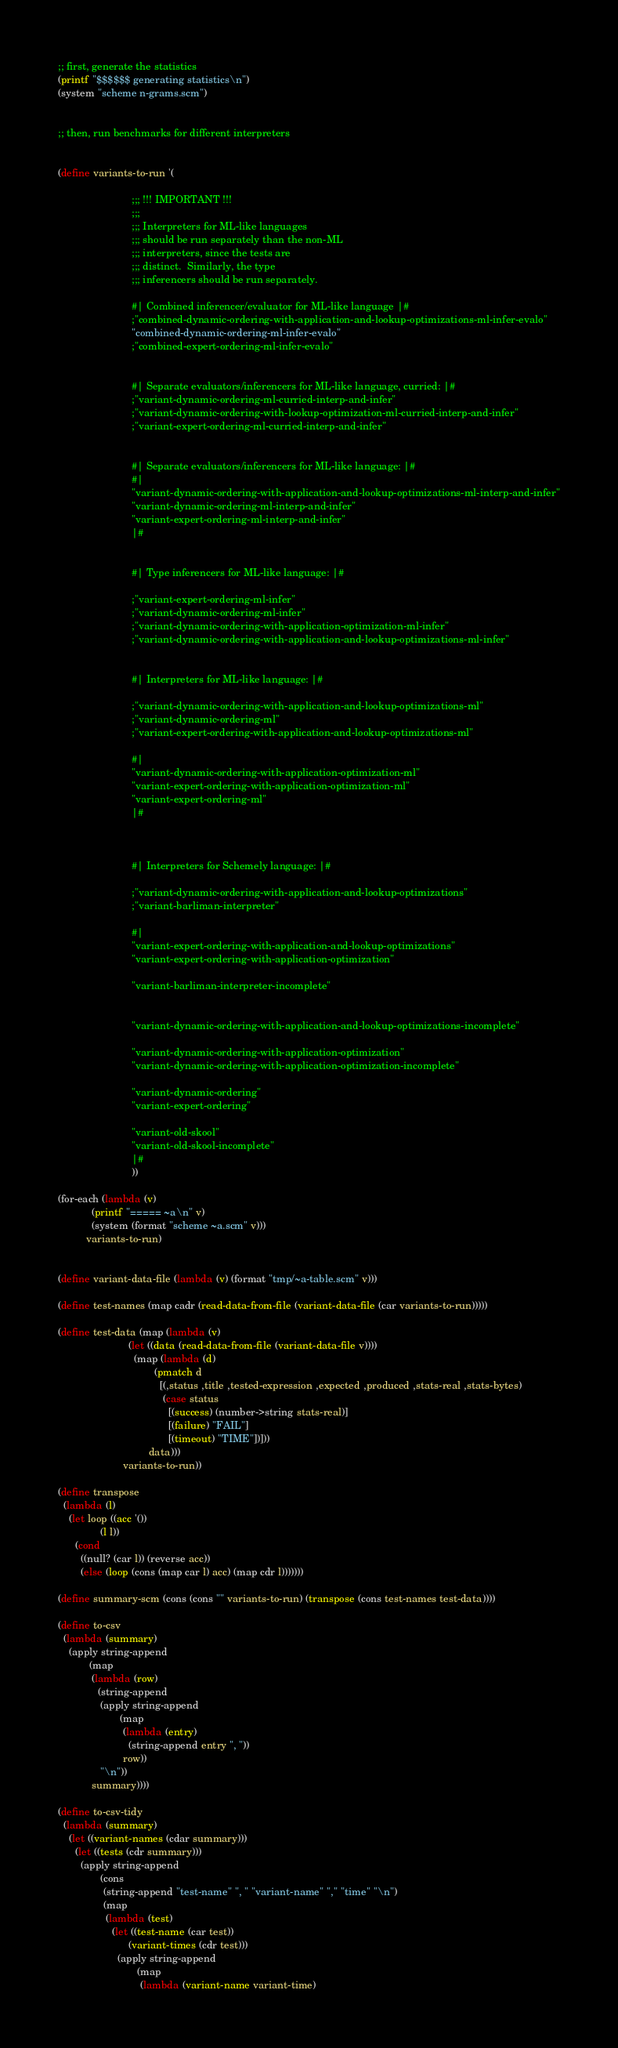<code> <loc_0><loc_0><loc_500><loc_500><_Scheme_>;; first, generate the statistics
(printf "$$$$$$ generating statistics\n")
(system "scheme n-grams.scm")


;; then, run benchmarks for different interpreters


(define variants-to-run '(
                          
                          ;;; !!! IMPORTANT !!!
                          ;;;
                          ;;; Interpreters for ML-like languages
                          ;;; should be run separately than the non-ML
                          ;;; interpreters, since the tests are
                          ;;; distinct.  Similarly, the type
                          ;;; inferencers should be run separately.

                          #| Combined inferencer/evaluator for ML-like language |#
                          ;"combined-dynamic-ordering-with-application-and-lookup-optimizations-ml-infer-evalo"
                          "combined-dynamic-ordering-ml-infer-evalo"
                          ;"combined-expert-ordering-ml-infer-evalo"
                          
                          
                          #| Separate evaluators/inferencers for ML-like language, curried: |#
                          ;"variant-dynamic-ordering-ml-curried-interp-and-infer"
                          ;"variant-dynamic-ordering-with-lookup-optimization-ml-curried-interp-and-infer"
                          ;"variant-expert-ordering-ml-curried-interp-and-infer"
                          
                          
                          #| Separate evaluators/inferencers for ML-like language: |#
                          #|
                          "variant-dynamic-ordering-with-application-and-lookup-optimizations-ml-interp-and-infer"
                          "variant-dynamic-ordering-ml-interp-and-infer"
                          "variant-expert-ordering-ml-interp-and-infer"
                          |#

                          
                          #| Type inferencers for ML-like language: |#
                          
                          ;"variant-expert-ordering-ml-infer"
                          ;"variant-dynamic-ordering-ml-infer"
                          ;"variant-dynamic-ordering-with-application-optimization-ml-infer"
                          ;"variant-dynamic-ordering-with-application-and-lookup-optimizations-ml-infer"
                          
                          
                          #| Interpreters for ML-like language: |#
                          
                          ;"variant-dynamic-ordering-with-application-and-lookup-optimizations-ml"
                          ;"variant-dynamic-ordering-ml"
                          ;"variant-expert-ordering-with-application-and-lookup-optimizations-ml"
                          
                          #|
                          "variant-dynamic-ordering-with-application-optimization-ml"                          
                          "variant-expert-ordering-with-application-optimization-ml"
                          "variant-expert-ordering-ml"                          
                          |#


                          
                          #| Interpreters for Schemely language: |#

                          ;"variant-dynamic-ordering-with-application-and-lookup-optimizations"
                          ;"variant-barliman-interpreter"
                          
                          #|
                          "variant-expert-ordering-with-application-and-lookup-optimizations"
                          "variant-expert-ordering-with-application-optimization"
                          
                          "variant-barliman-interpreter-incomplete"
                          
                          
                          "variant-dynamic-ordering-with-application-and-lookup-optimizations-incomplete"
                          
                          "variant-dynamic-ordering-with-application-optimization"
                          "variant-dynamic-ordering-with-application-optimization-incomplete"
                          
                          "variant-dynamic-ordering"
                          "variant-expert-ordering"
                          
                          "variant-old-skool"
                          "variant-old-skool-incomplete"
                          |#
                          ))

(for-each (lambda (v)
            (printf "===== ~a\n" v)
            (system (format "scheme ~a.scm" v)))
          variants-to-run)


(define variant-data-file (lambda (v) (format "tmp/~a-table.scm" v)))

(define test-names (map cadr (read-data-from-file (variant-data-file (car variants-to-run)))))

(define test-data (map (lambda (v)
                         (let ((data (read-data-from-file (variant-data-file v))))
                           (map (lambda (d)
                                  (pmatch d
                                    [(,status ,title ,tested-expression ,expected ,produced ,stats-real ,stats-bytes)
                                     (case status
                                       [(success) (number->string stats-real)]
                                       [(failure) "FAIL"]
                                       [(timeout) "TIME"])]))
                                data)))
                       variants-to-run))

(define transpose
  (lambda (l)
    (let loop ((acc '())
               (l l))
      (cond
        ((null? (car l)) (reverse acc))
        (else (loop (cons (map car l) acc) (map cdr l)))))))

(define summary-scm (cons (cons "" variants-to-run) (transpose (cons test-names test-data))))

(define to-csv
  (lambda (summary)
    (apply string-append
           (map
            (lambda (row)
              (string-append
               (apply string-append
                      (map
                       (lambda (entry)
                         (string-append entry ", "))
                       row))
               "\n"))
            summary))))

(define to-csv-tidy
  (lambda (summary)
    (let ((variant-names (cdar summary)))
      (let ((tests (cdr summary)))
        (apply string-append
               (cons
                (string-append "test-name" ", " "variant-name" "," "time" "\n")
                (map
                 (lambda (test)
                   (let ((test-name (car test))
                         (variant-times (cdr test)))
                     (apply string-append
                            (map
                             (lambda (variant-name variant-time)</code> 